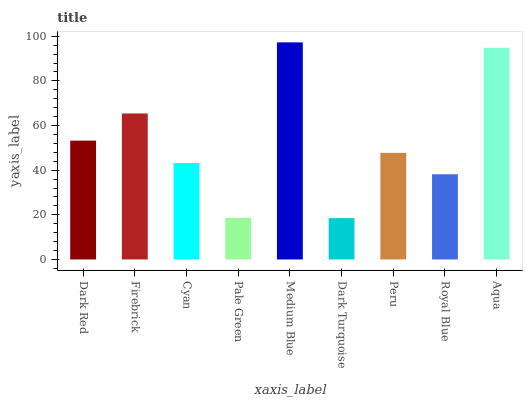Is Dark Turquoise the minimum?
Answer yes or no. Yes. Is Medium Blue the maximum?
Answer yes or no. Yes. Is Firebrick the minimum?
Answer yes or no. No. Is Firebrick the maximum?
Answer yes or no. No. Is Firebrick greater than Dark Red?
Answer yes or no. Yes. Is Dark Red less than Firebrick?
Answer yes or no. Yes. Is Dark Red greater than Firebrick?
Answer yes or no. No. Is Firebrick less than Dark Red?
Answer yes or no. No. Is Peru the high median?
Answer yes or no. Yes. Is Peru the low median?
Answer yes or no. Yes. Is Dark Red the high median?
Answer yes or no. No. Is Cyan the low median?
Answer yes or no. No. 